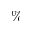<formula> <loc_0><loc_0><loc_500><loc_500>\%</formula> 